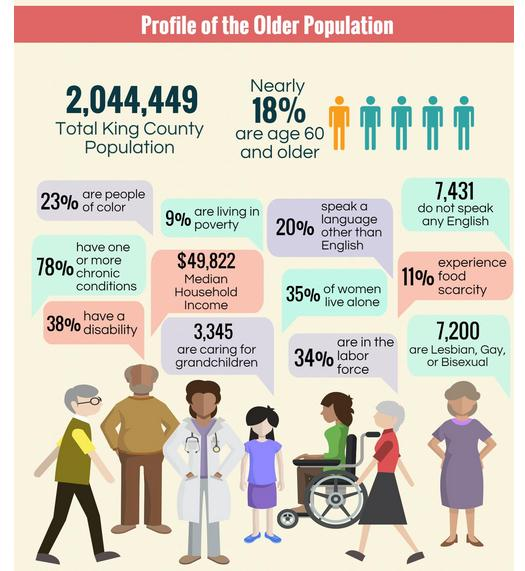Point out several critical features in this image. A large majority, 89%, of individuals did not experience food scarcity. Approximately 66% of people are not currently participating in the labor force. According to recent data, 91% of individuals are not living in poverty. Sixty-two percent of the individuals in the sample did not have a disability. According to the provided information, 77% of people are not of color. 